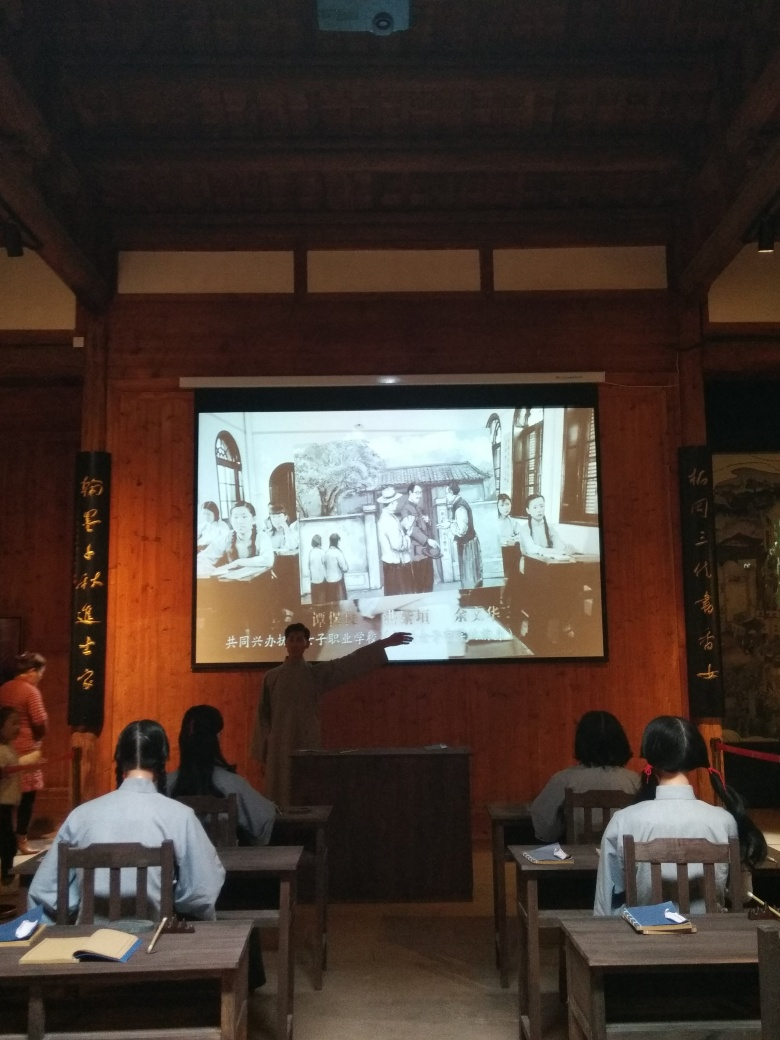What can you tell me about the room's architecture and design? The room exhibits characteristics of traditional East Asian architecture, with wooden beam construction and panels that likely facilitate division of the space. The aesthetic suggests a blend of preservation of historical design with functionality for modern educational purposes. Is there anything interesting about the lighting or how the image is taken? The photo appears to have been taken in ambient indoor lighting, which casts a uniform light across the scene without causing overly harsh shadows. The lighting, in conjunction with the camera's settings, may have resulted in some loss of detail as previously noted. 